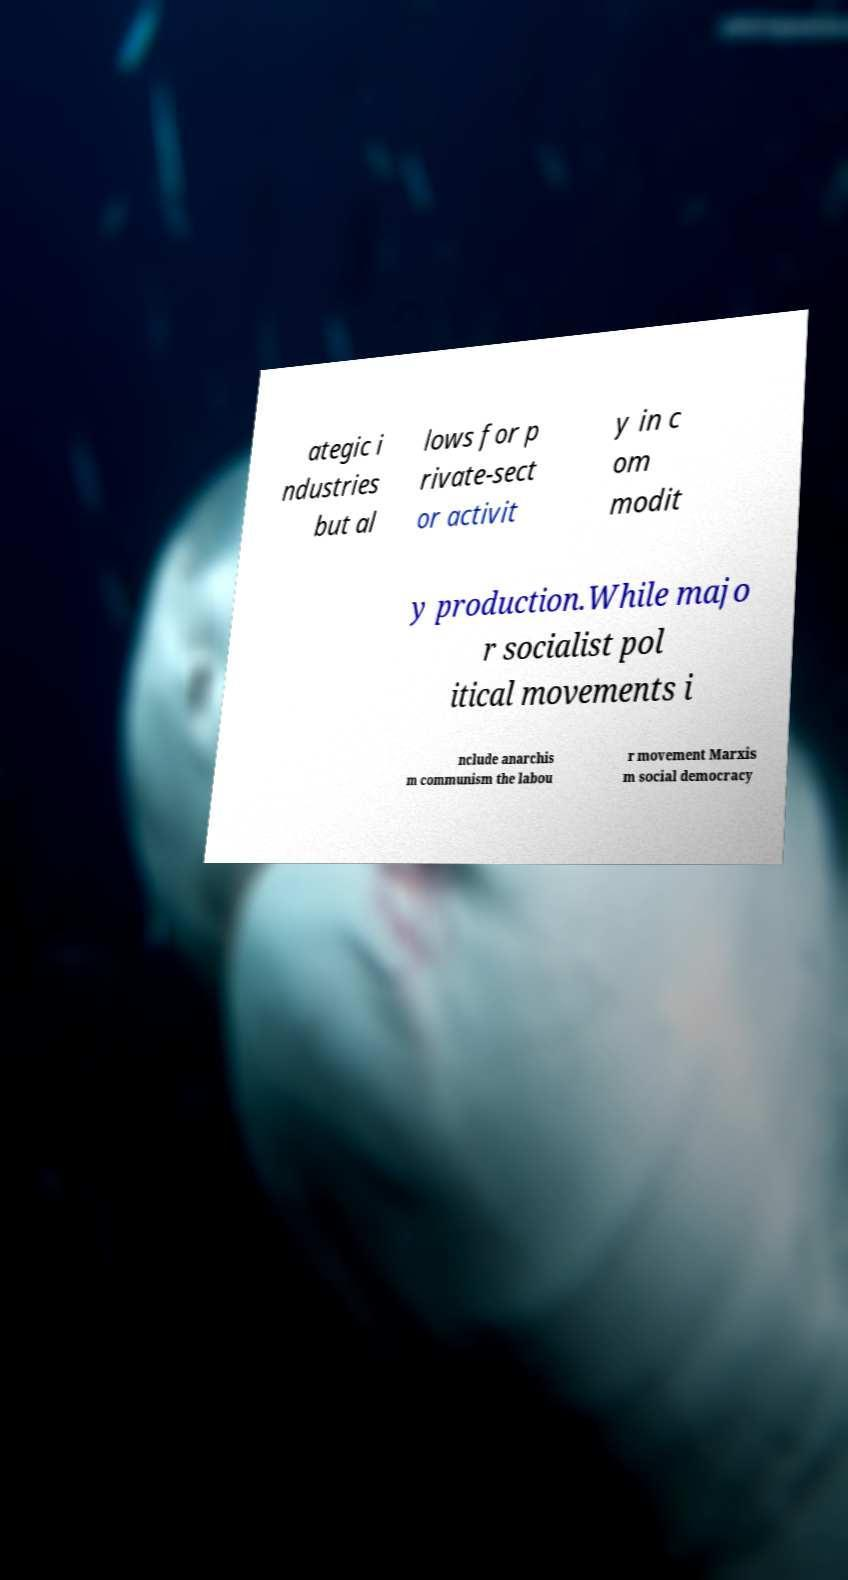What messages or text are displayed in this image? I need them in a readable, typed format. ategic i ndustries but al lows for p rivate-sect or activit y in c om modit y production.While majo r socialist pol itical movements i nclude anarchis m communism the labou r movement Marxis m social democracy 